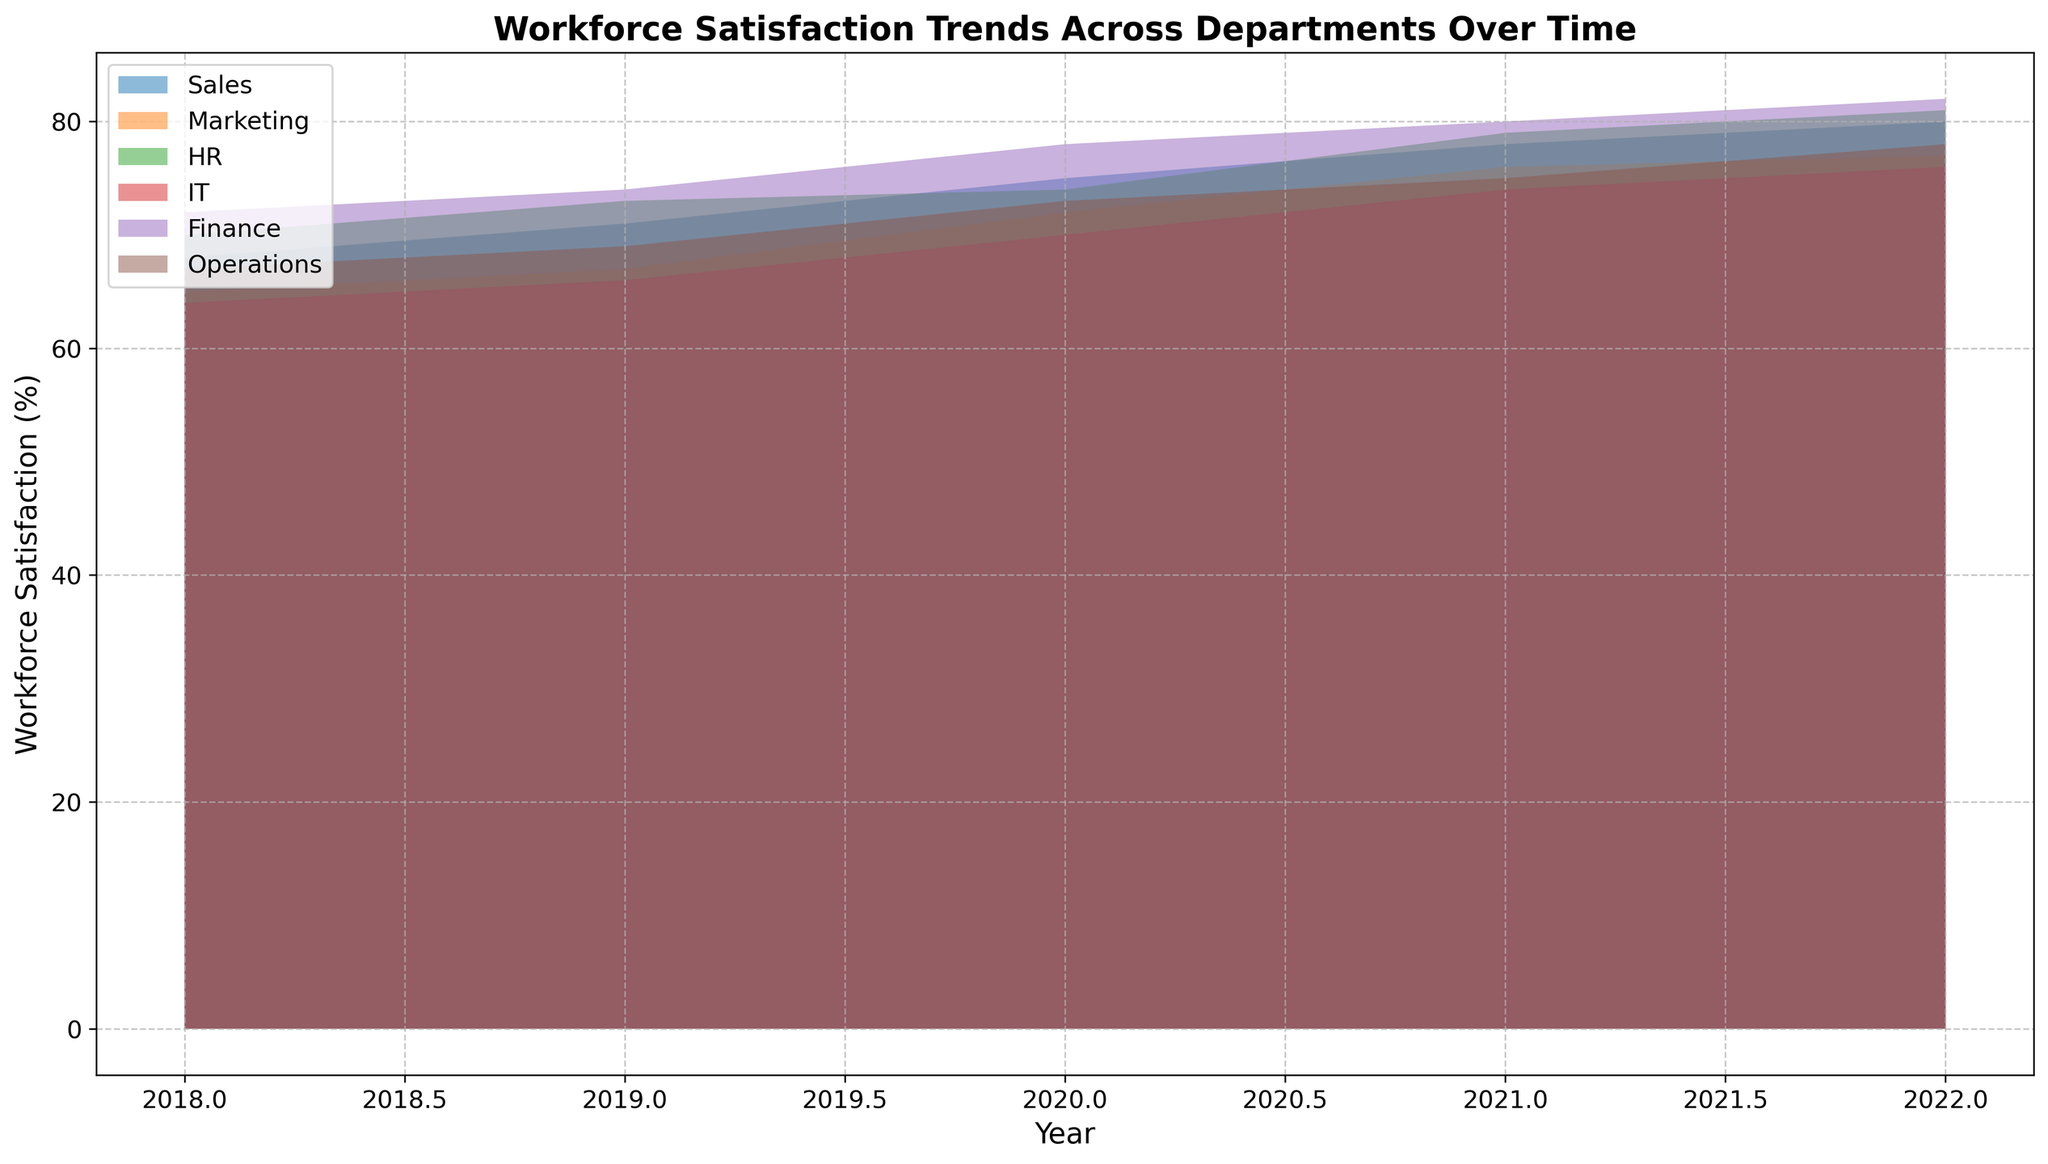What is the general trend of workforce satisfaction in the Finance department over the years? Observing the area chart, the workforce satisfaction in the Finance department shows an upward trend from 2018 to 2022, starting from 72% and increasing every year to reach 82% in 2022.
Answer: An upward trend Which department had the highest workforce satisfaction in 2020? Looking at the relative heights of the areas in 2020, the Finance department had the highest workforce satisfaction at 78%.
Answer: Finance How did the workforce satisfaction in the Sales department change from 2019 to 2021? Checking the chart, the satisfaction in Sales increased from 71% in 2019 to 78% in 2021.
Answer: Increased from 71% to 78% In which year did the IT department surpass 70% workforce satisfaction for the first time? Analyzing the chart, the IT department first surpassed 70% workforce satisfaction in 2020, where it exactly reached 70%.
Answer: 2020 What is the difference in workforce satisfaction between HR and Marketing in 2022? According to the chart, HR satisfaction in 2022 is 81%, and Marketing is 77%. The difference between them is 81% - 77% = 4%.
Answer: 4% Which department showed the most significant improvement in workforce satisfaction from 2018 to 2022? By comparing the increase in the areas, the IT department displayed significant improvement from 64% in 2018 to 76% in 2022, a difference of 12%.
Answer: IT Compare the workforce satisfaction trends between Operations and Sales departments from 2018 to 2022. Observing the patterns, both departments show an increasing trend. Sales increases from 68% to 80%, and Operations increases from 67% to 78%. Sales has a higher starting and ending point compared to Operations.
Answer: Both increasing, Sales higher What is the average workforce satisfaction in the Marketing department from 2018 to 2022? The satisfaction values for Marketing are 65%, 67%, 72%, 76%, and 77%. The average is calculated as (65+67+72+76+77)/5 = 71.4%.
Answer: 71.4% Which year showed the largest overall improvement in workforce satisfaction for all departments? By examining the chart for the steepest increase in satisfaction across all areas, the year between 2019 and 2020 shows the largest overall improvement.
Answer: 2020 